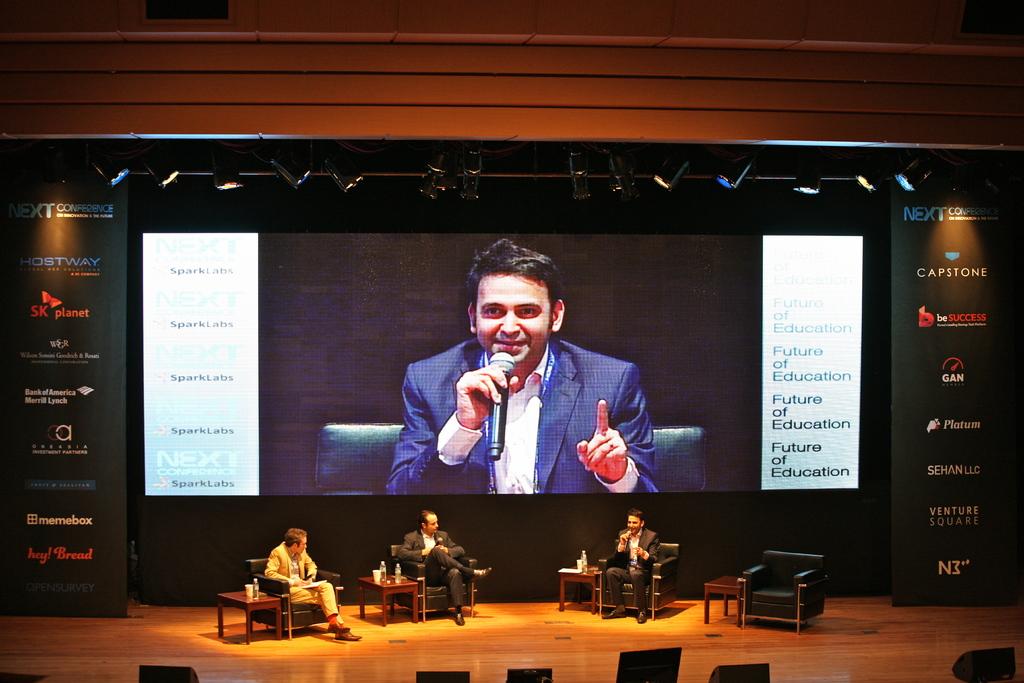What is the future being discussed here?
Provide a short and direct response. Education. The what of education?
Offer a terse response. Future. 